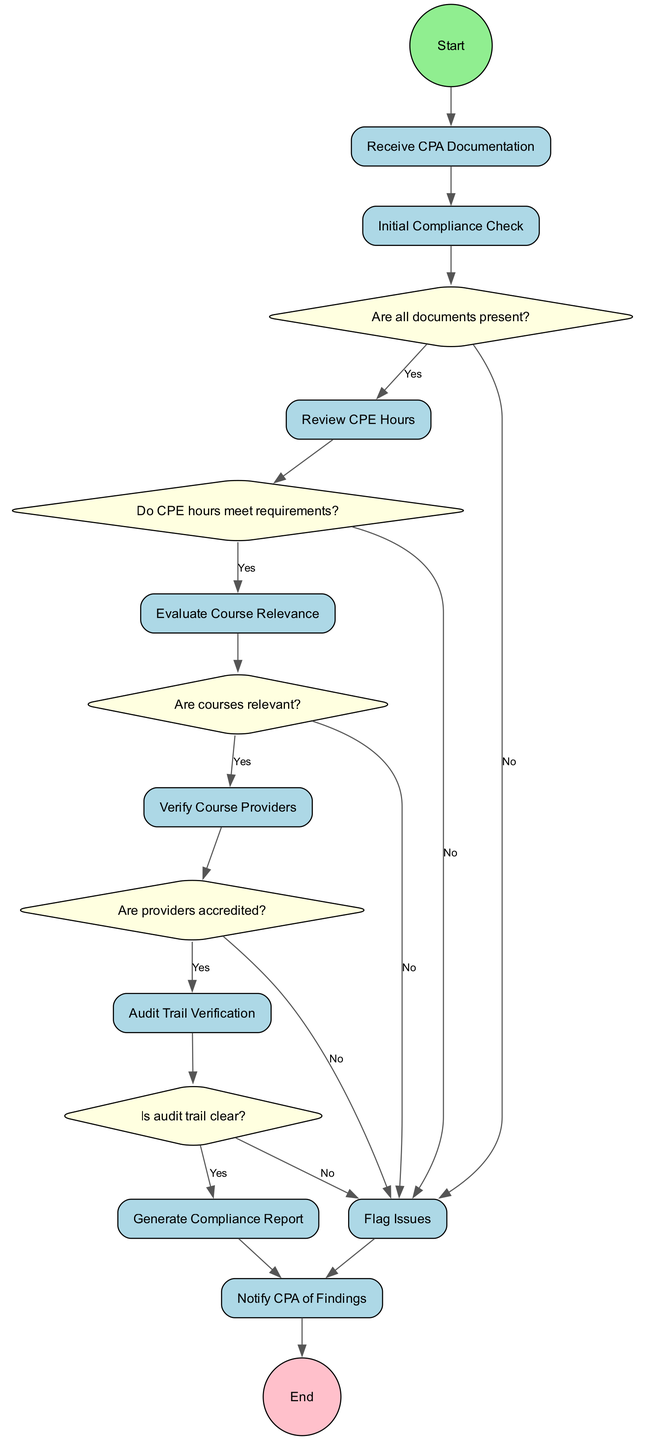What's the start node in the diagram? The start node is explicitly labeled as "Start" in the diagram, indicating where the process begins.
Answer: Start How many activities are represented in the diagram? There are nine activities listed in the diagram, which are directly mentioned in the activities section.
Answer: 9 What is the first decision point after receiving CPA documentation? After receiving CPA documentation, the first decision point is whether all documents are present, identified by decision node "10".
Answer: Are all documents present? Which activity follows the successful verification of CPE hours? Upon confirming that the CPE hours meet requirements, the next activity is to evaluate course relevance, as per the decision flow from node "11" to "4".
Answer: Evaluate Course Relevance What happens if the audit trail is not clear? If the audit trail is not clear, the process flows to the activity of flagging issues, which is represented by the transition from decision node "14" to activity node "7".
Answer: Flag Issues What is the outcome of flagging discrepancies? Flagging discrepancies leads to the same next step as an unclear audit trail, which is to notify the CPA of findings (activity node "9").
Answer: Notify CPA of Findings What is the total number of decision nodes in the diagram? There are five decision nodes in the diagram, which evaluate various conditions regarding the CPA's compliance with CPE requirements.
Answer: 5 Is the compliance report generated before notifying the CPA? Yes, the compliance report is generated as the activity following the successful completion of all checks, before notifying the CPA of findings.
Answer: Yes What are the last two activities in the process? The last two activities in the process are generating the compliance report and notifying the CPA of findings, indicating the conclusion of the review process.
Answer: Generate Compliance Report, Notify CPA of Findings 